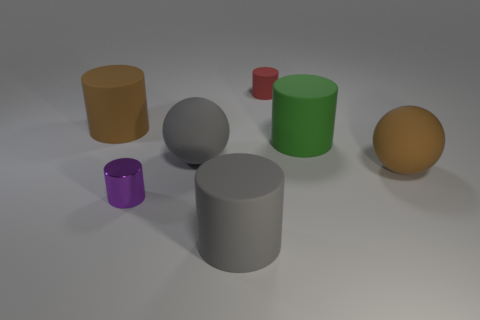Add 2 red rubber cylinders. How many objects exist? 9 Subtract all green cylinders. How many cylinders are left? 4 Subtract all large gray matte cylinders. How many cylinders are left? 4 Subtract all blue cylinders. Subtract all red cubes. How many cylinders are left? 5 Subtract all balls. How many objects are left? 5 Add 5 brown matte things. How many brown matte things exist? 7 Subtract 0 brown blocks. How many objects are left? 7 Subtract all green rubber cylinders. Subtract all green cylinders. How many objects are left? 5 Add 2 large gray rubber things. How many large gray rubber things are left? 4 